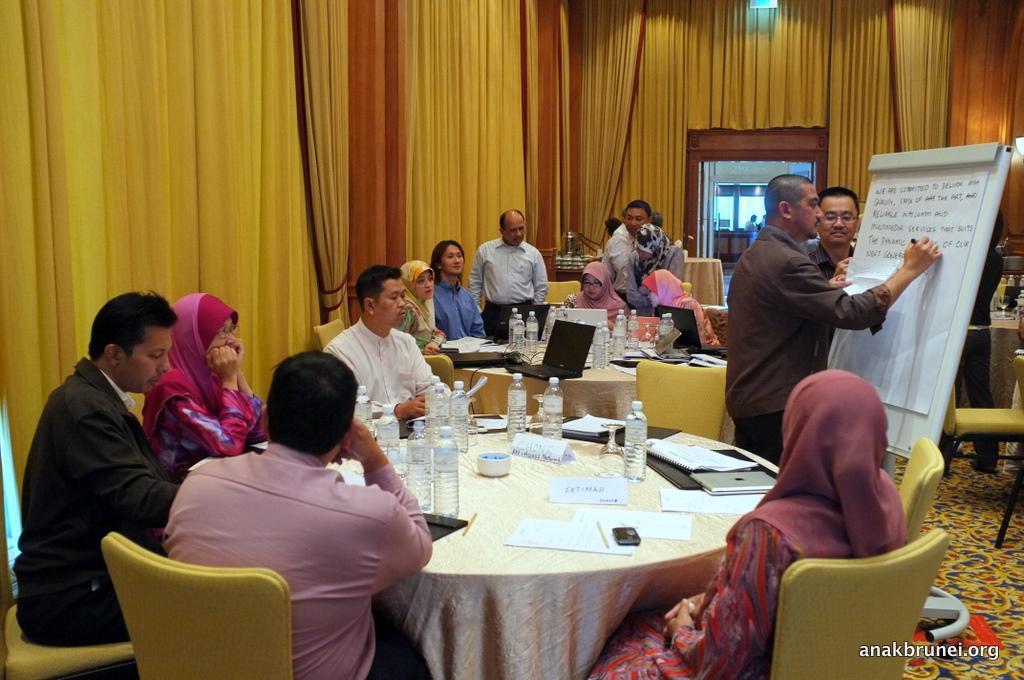How would you summarize this image in a sentence or two? In this picture there are several people sitting on a white round table and water bottles, notebooks on top of it. There are two guys to the right side of the image writing on the board. In the background we observe yellow curtains. 